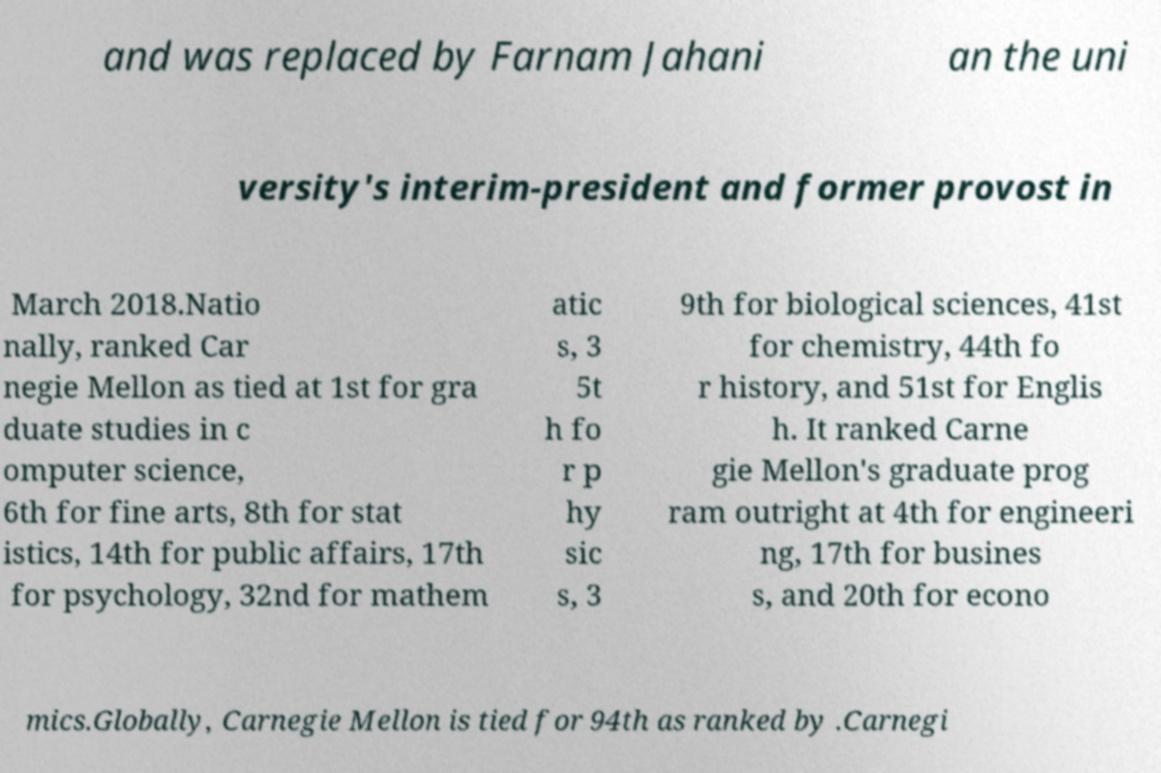For documentation purposes, I need the text within this image transcribed. Could you provide that? and was replaced by Farnam Jahani an the uni versity's interim-president and former provost in March 2018.Natio nally, ranked Car negie Mellon as tied at 1st for gra duate studies in c omputer science, 6th for fine arts, 8th for stat istics, 14th for public affairs, 17th for psychology, 32nd for mathem atic s, 3 5t h fo r p hy sic s, 3 9th for biological sciences, 41st for chemistry, 44th fo r history, and 51st for Englis h. It ranked Carne gie Mellon's graduate prog ram outright at 4th for engineeri ng, 17th for busines s, and 20th for econo mics.Globally, Carnegie Mellon is tied for 94th as ranked by .Carnegi 